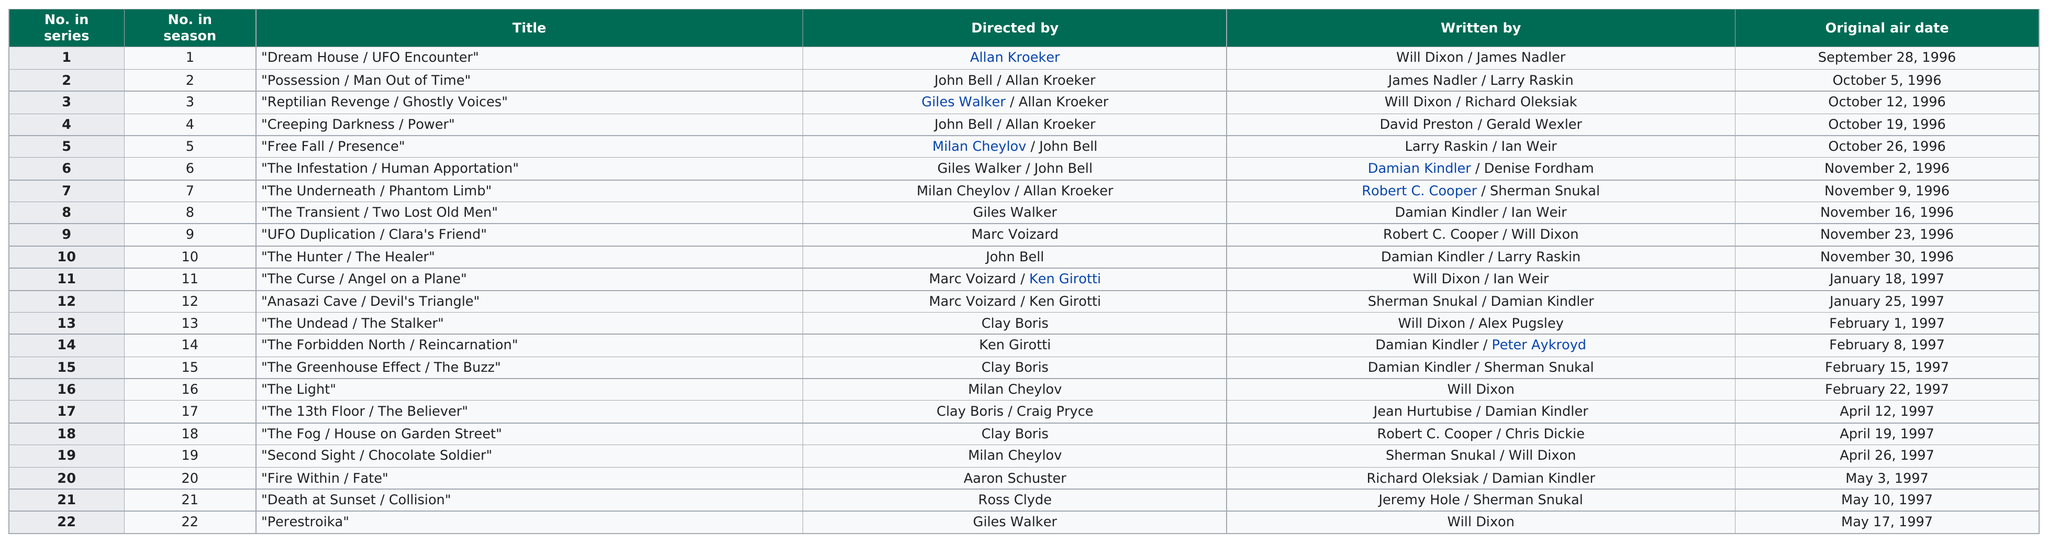Mention a couple of crucial points in this snapshot. The number of times a title was directed by Milan Cheylov is 4. After the first episode, it is unknown when Dixon's next written episode will be. The series 'Psi Factor: Chronicles of the Paranormal' originally aired 10 episodes in 1996. The last episode of the first season is called "Perestroika," "Perestroika". In November, the total number of titles aired was 5. 